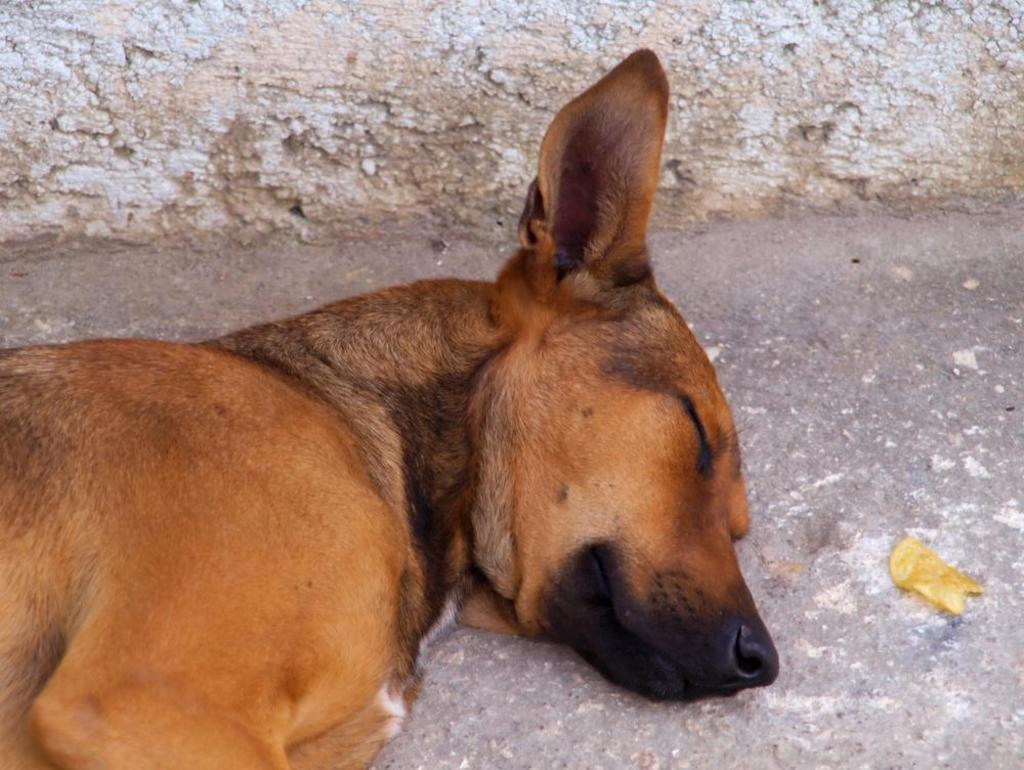What animal can be seen in the picture? There is a dog in the picture. What is the dog doing in the picture? The dog is laying on the ground. What is the color of the dog in the picture? The dog is brown in color. What can be seen in the background of the picture? There is a wall visible in the picture. Where is the toothbrush located in the picture? There is no toothbrush present in the picture. What direction is the wind blowing in the picture? There is no indication of wind or its direction in the picture. 